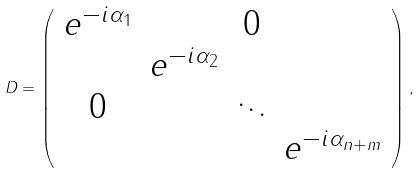<formula> <loc_0><loc_0><loc_500><loc_500>D = \left ( \begin{array} { c c c c } e ^ { - i \alpha _ { 1 } } & & 0 & \\ & e ^ { - i \alpha _ { 2 } } & & \\ 0 & & \ddots & \\ & & & e ^ { - i \alpha _ { n + m } } \end{array} \right ) ,</formula> 